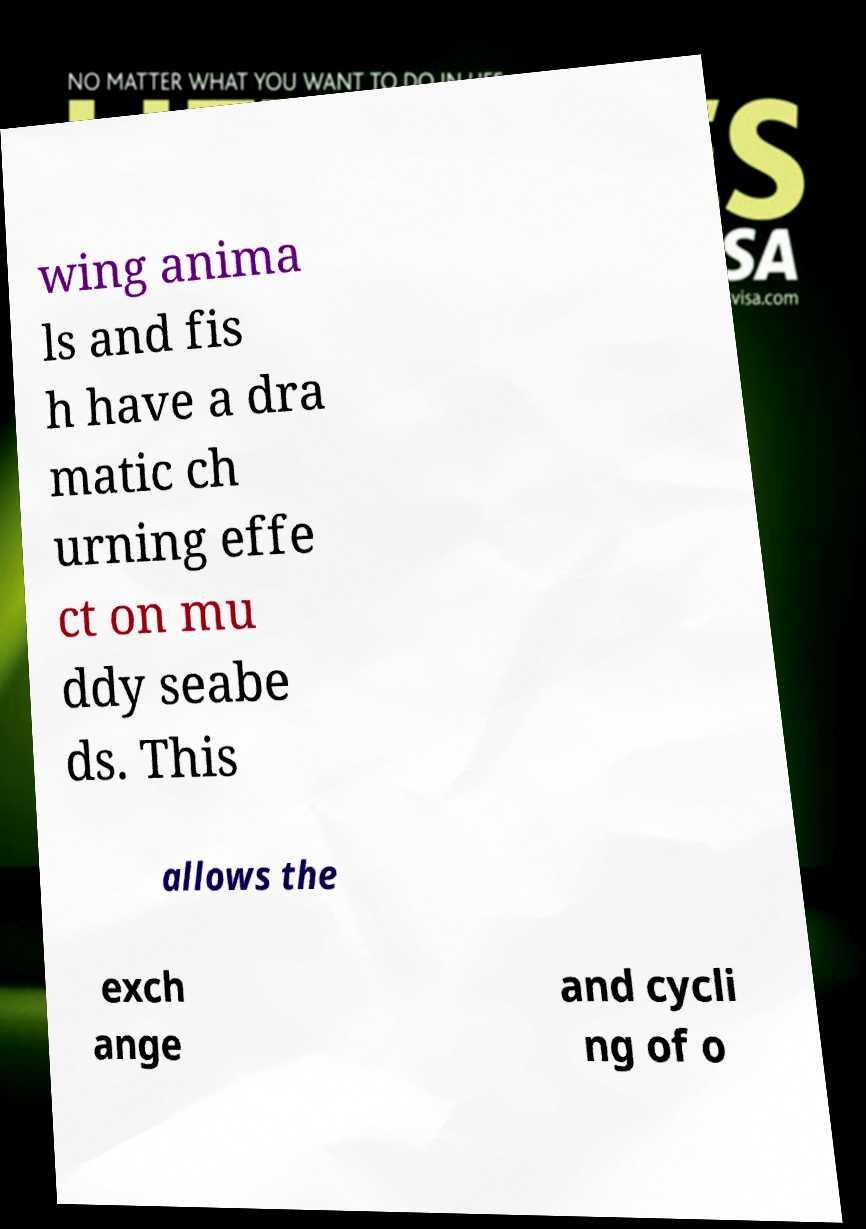For documentation purposes, I need the text within this image transcribed. Could you provide that? wing anima ls and fis h have a dra matic ch urning effe ct on mu ddy seabe ds. This allows the exch ange and cycli ng of o 